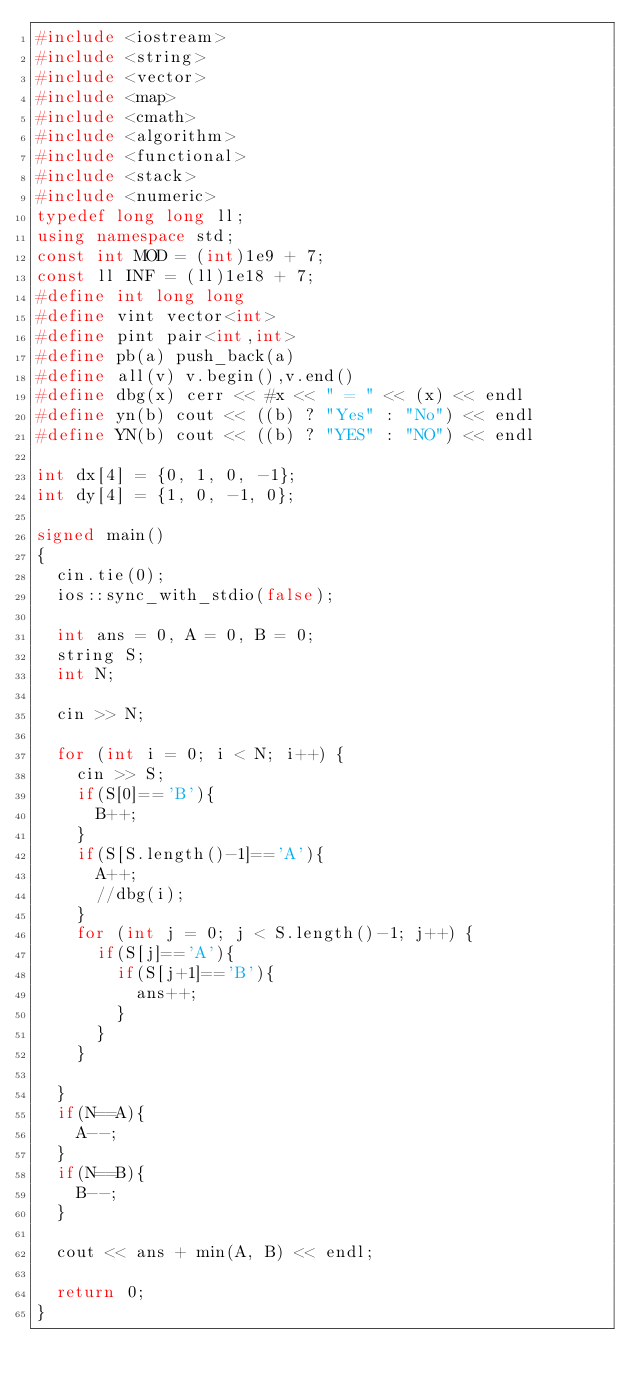Convert code to text. <code><loc_0><loc_0><loc_500><loc_500><_C++_>#include <iostream>
#include <string>
#include <vector>
#include <map>
#include <cmath>
#include <algorithm>
#include <functional>
#include <stack>
#include <numeric>
typedef long long ll;
using namespace std;
const int MOD = (int)1e9 + 7;
const ll INF = (ll)1e18 + 7;
#define int long long
#define vint vector<int>
#define pint pair<int,int>
#define pb(a) push_back(a)
#define all(v) v.begin(),v.end()
#define dbg(x) cerr << #x << " = " << (x) << endl
#define yn(b) cout << ((b) ? "Yes" : "No") << endl
#define YN(b) cout << ((b) ? "YES" : "NO") << endl

int dx[4] = {0, 1, 0, -1};
int dy[4] = {1, 0, -1, 0};

signed main()
{
	cin.tie(0);
	ios::sync_with_stdio(false);

	int ans = 0, A = 0, B = 0;
	string S;
	int N;

	cin >> N;

	for (int i = 0; i < N; i++) {
		cin >> S;
		if(S[0]=='B'){
			B++;
		}
		if(S[S.length()-1]=='A'){
			A++;
			//dbg(i);
		}
		for (int j = 0; j < S.length()-1; j++) {
			if(S[j]=='A'){
				if(S[j+1]=='B'){
					ans++;
				}
			}
		}

	}
	if(N==A){
		A--;
	}
	if(N==B){
		B--;
	}

	cout << ans + min(A, B) << endl;

	return 0;
}</code> 